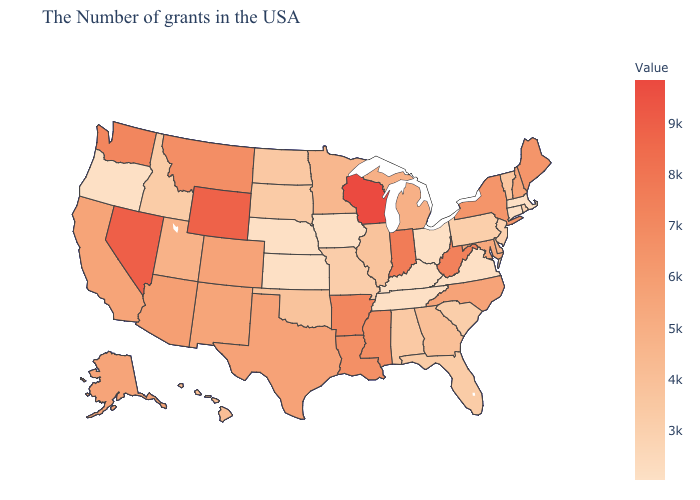Which states have the lowest value in the USA?
Concise answer only. Massachusetts, Connecticut, Virginia, Ohio, Kentucky, Tennessee, Iowa, Kansas, Nebraska, Oregon. Among the states that border Pennsylvania , does West Virginia have the lowest value?
Short answer required. No. Does Maine have a lower value than Wisconsin?
Give a very brief answer. Yes. 